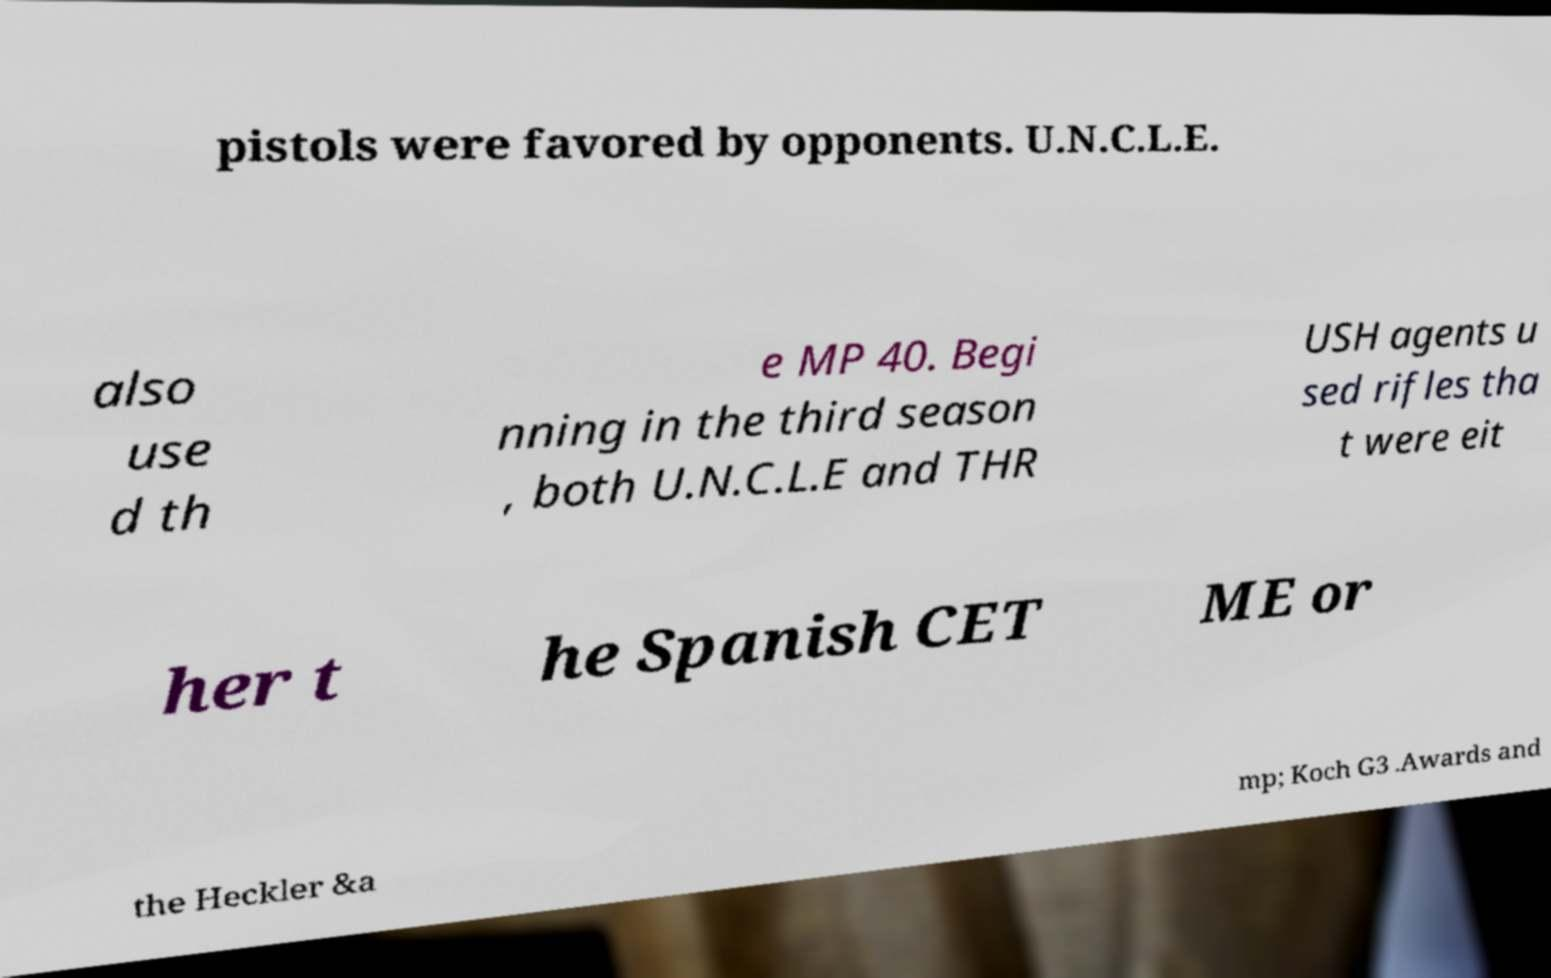Could you extract and type out the text from this image? pistols were favored by opponents. U.N.C.L.E. also use d th e MP 40. Begi nning in the third season , both U.N.C.L.E and THR USH agents u sed rifles tha t were eit her t he Spanish CET ME or the Heckler &a mp; Koch G3 .Awards and 